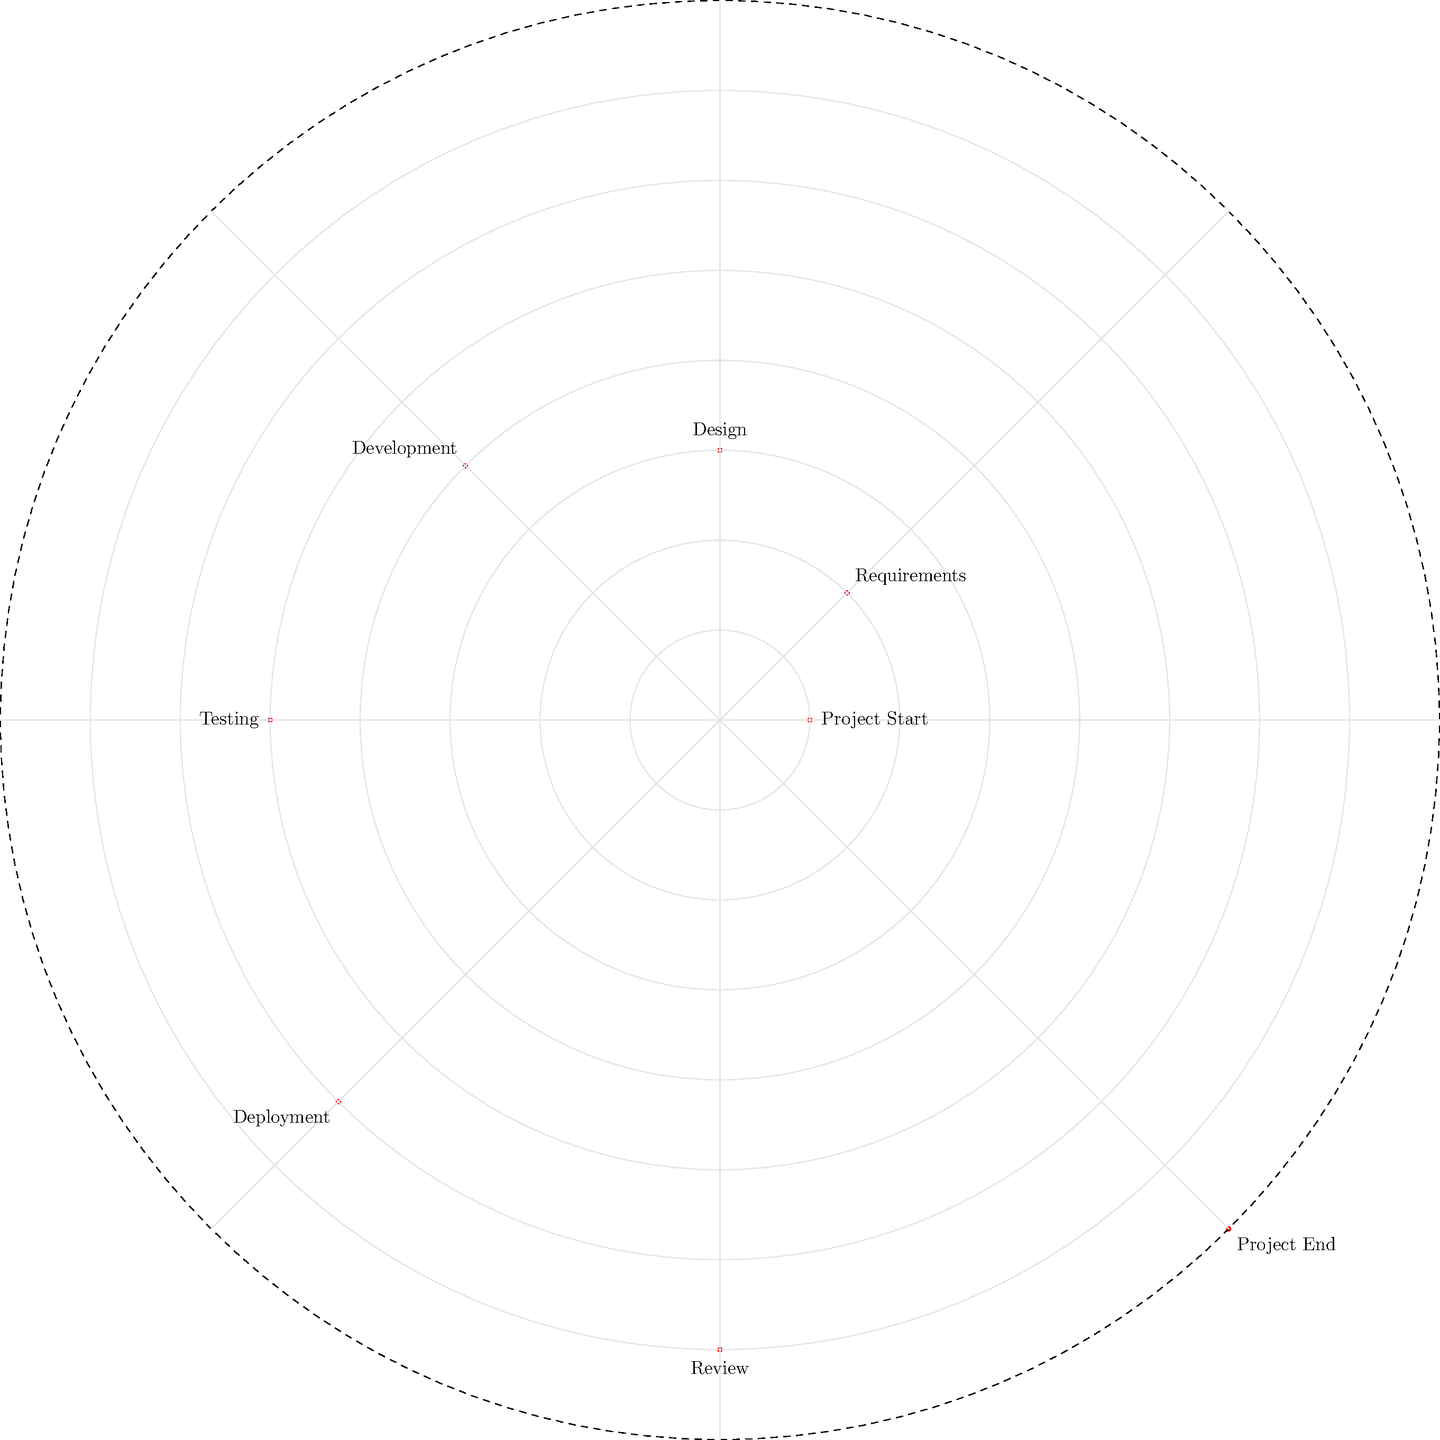In the polar coordinate representation of project management timelines, which phase is located at approximately $(6, 225°)$ and what does this position signify in terms of project progression? To answer this question, let's break it down step-by-step:

1. In polar coordinates, a point is represented as $(r, \theta)$, where $r$ is the distance from the origin and $\theta$ is the angle from the positive x-axis.

2. The given coordinates are approximately $(6, 225°)$.

3. Looking at the diagram, we can see that each concentric circle represents a unit of radial distance, and the angles are marked in 45° increments.

4. Tracing to the point $(6, 225°)$, we find that it corresponds to the "Deployment" phase.

5. In terms of project progression, this position signifies:
   a. The radial distance of 6 out of 8 indicates that the project is about 75% complete.
   b. The angle of 225° (or 5/8 of a full rotation) also supports that the project is in its later stages.

6. The "Deployment" phase typically occurs near the end of a project, after development and testing, but before the final review and project completion.

This representation allows project managers to visualize both the sequence of phases (angular position) and the relative duration or effort required for each phase (radial distance) in a single, compact diagram.
Answer: Deployment; 75% project completion 